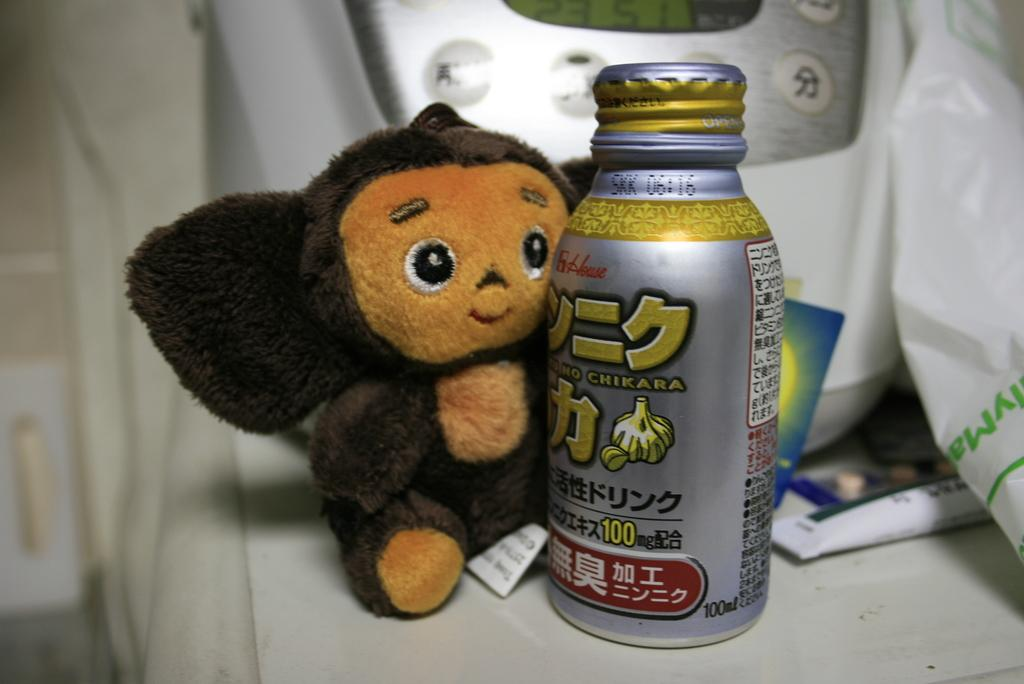What is the main subject of the image? There is a doll in the image. What else can be seen on the table in the image? There is a syrup bottle on a table in the image. What object is visible in the background of the image? There is a telephone in the background of the image. How many babies are crawling on the floor in the image? There are no babies present in the image. What type of box is being used to store the doll in the image? There is no box present in the image; the doll is not being stored. 